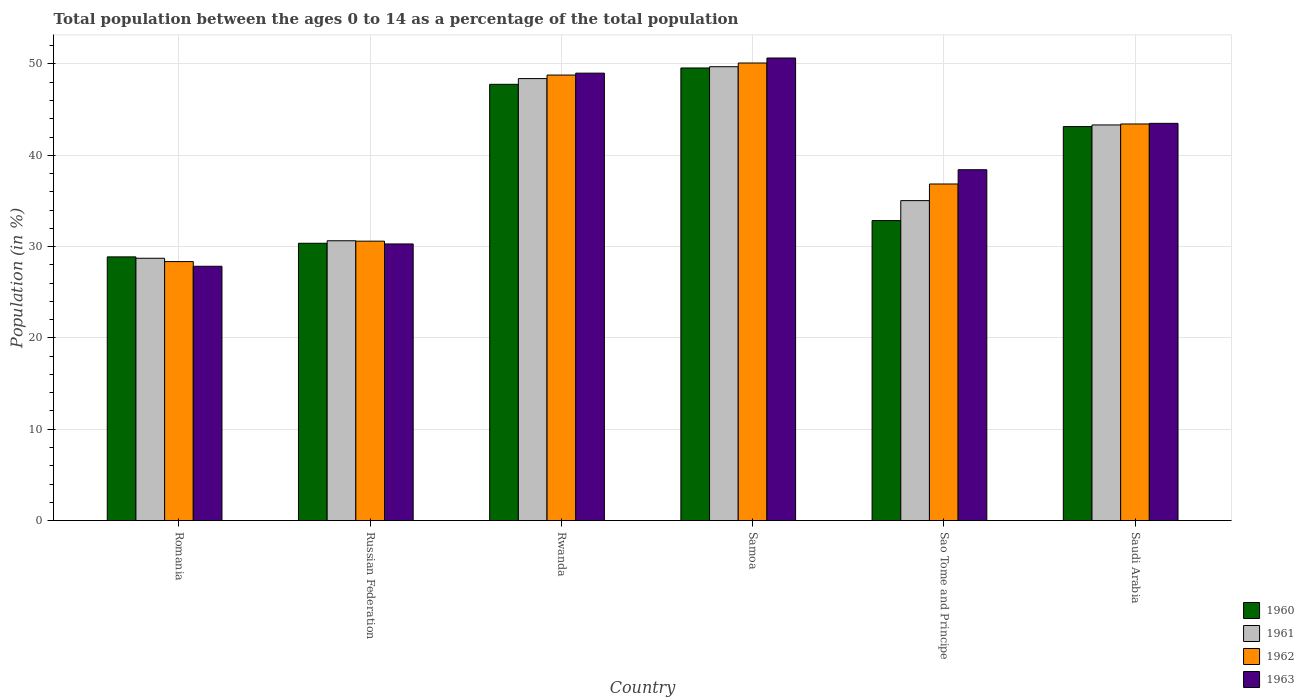How many groups of bars are there?
Give a very brief answer. 6. Are the number of bars on each tick of the X-axis equal?
Provide a succinct answer. Yes. How many bars are there on the 3rd tick from the left?
Your answer should be very brief. 4. How many bars are there on the 1st tick from the right?
Keep it short and to the point. 4. What is the label of the 3rd group of bars from the left?
Offer a terse response. Rwanda. In how many cases, is the number of bars for a given country not equal to the number of legend labels?
Provide a short and direct response. 0. What is the percentage of the population ages 0 to 14 in 1961 in Rwanda?
Your answer should be compact. 48.4. Across all countries, what is the maximum percentage of the population ages 0 to 14 in 1961?
Offer a terse response. 49.7. Across all countries, what is the minimum percentage of the population ages 0 to 14 in 1961?
Your answer should be compact. 28.73. In which country was the percentage of the population ages 0 to 14 in 1961 maximum?
Your response must be concise. Samoa. In which country was the percentage of the population ages 0 to 14 in 1962 minimum?
Give a very brief answer. Romania. What is the total percentage of the population ages 0 to 14 in 1960 in the graph?
Give a very brief answer. 232.57. What is the difference between the percentage of the population ages 0 to 14 in 1962 in Rwanda and that in Saudi Arabia?
Make the answer very short. 5.36. What is the difference between the percentage of the population ages 0 to 14 in 1961 in Romania and the percentage of the population ages 0 to 14 in 1962 in Sao Tome and Principe?
Provide a short and direct response. -8.13. What is the average percentage of the population ages 0 to 14 in 1962 per country?
Provide a succinct answer. 39.69. What is the difference between the percentage of the population ages 0 to 14 of/in 1962 and percentage of the population ages 0 to 14 of/in 1960 in Romania?
Give a very brief answer. -0.51. What is the ratio of the percentage of the population ages 0 to 14 in 1960 in Samoa to that in Sao Tome and Principe?
Keep it short and to the point. 1.51. What is the difference between the highest and the second highest percentage of the population ages 0 to 14 in 1960?
Keep it short and to the point. 6.42. What is the difference between the highest and the lowest percentage of the population ages 0 to 14 in 1963?
Give a very brief answer. 22.81. Is the sum of the percentage of the population ages 0 to 14 in 1962 in Russian Federation and Rwanda greater than the maximum percentage of the population ages 0 to 14 in 1960 across all countries?
Your answer should be compact. Yes. Is it the case that in every country, the sum of the percentage of the population ages 0 to 14 in 1961 and percentage of the population ages 0 to 14 in 1960 is greater than the sum of percentage of the population ages 0 to 14 in 1962 and percentage of the population ages 0 to 14 in 1963?
Provide a short and direct response. No. What does the 2nd bar from the right in Romania represents?
Your response must be concise. 1962. Is it the case that in every country, the sum of the percentage of the population ages 0 to 14 in 1962 and percentage of the population ages 0 to 14 in 1963 is greater than the percentage of the population ages 0 to 14 in 1961?
Keep it short and to the point. Yes. How many bars are there?
Give a very brief answer. 24. Are all the bars in the graph horizontal?
Ensure brevity in your answer.  No. How many countries are there in the graph?
Provide a succinct answer. 6. Does the graph contain any zero values?
Ensure brevity in your answer.  No. Does the graph contain grids?
Offer a terse response. Yes. What is the title of the graph?
Make the answer very short. Total population between the ages 0 to 14 as a percentage of the total population. Does "2003" appear as one of the legend labels in the graph?
Offer a very short reply. No. What is the label or title of the X-axis?
Your answer should be compact. Country. What is the Population (in %) in 1960 in Romania?
Keep it short and to the point. 28.88. What is the Population (in %) in 1961 in Romania?
Provide a succinct answer. 28.73. What is the Population (in %) in 1962 in Romania?
Your answer should be very brief. 28.36. What is the Population (in %) in 1963 in Romania?
Provide a succinct answer. 27.85. What is the Population (in %) in 1960 in Russian Federation?
Offer a very short reply. 30.37. What is the Population (in %) of 1961 in Russian Federation?
Your response must be concise. 30.64. What is the Population (in %) in 1962 in Russian Federation?
Make the answer very short. 30.6. What is the Population (in %) of 1963 in Russian Federation?
Ensure brevity in your answer.  30.29. What is the Population (in %) in 1960 in Rwanda?
Your answer should be very brief. 47.77. What is the Population (in %) of 1961 in Rwanda?
Give a very brief answer. 48.4. What is the Population (in %) of 1962 in Rwanda?
Ensure brevity in your answer.  48.79. What is the Population (in %) in 1963 in Rwanda?
Your answer should be compact. 49. What is the Population (in %) of 1960 in Samoa?
Offer a very short reply. 49.56. What is the Population (in %) in 1961 in Samoa?
Your response must be concise. 49.7. What is the Population (in %) in 1962 in Samoa?
Offer a very short reply. 50.11. What is the Population (in %) of 1963 in Samoa?
Keep it short and to the point. 50.65. What is the Population (in %) in 1960 in Sao Tome and Principe?
Your response must be concise. 32.85. What is the Population (in %) in 1961 in Sao Tome and Principe?
Your response must be concise. 35.04. What is the Population (in %) of 1962 in Sao Tome and Principe?
Offer a very short reply. 36.86. What is the Population (in %) in 1963 in Sao Tome and Principe?
Your answer should be very brief. 38.42. What is the Population (in %) of 1960 in Saudi Arabia?
Your response must be concise. 43.14. What is the Population (in %) in 1961 in Saudi Arabia?
Make the answer very short. 43.32. What is the Population (in %) of 1962 in Saudi Arabia?
Provide a short and direct response. 43.43. What is the Population (in %) in 1963 in Saudi Arabia?
Your answer should be compact. 43.5. Across all countries, what is the maximum Population (in %) of 1960?
Your answer should be compact. 49.56. Across all countries, what is the maximum Population (in %) of 1961?
Give a very brief answer. 49.7. Across all countries, what is the maximum Population (in %) of 1962?
Ensure brevity in your answer.  50.11. Across all countries, what is the maximum Population (in %) of 1963?
Ensure brevity in your answer.  50.65. Across all countries, what is the minimum Population (in %) in 1960?
Your answer should be compact. 28.88. Across all countries, what is the minimum Population (in %) of 1961?
Your answer should be very brief. 28.73. Across all countries, what is the minimum Population (in %) in 1962?
Offer a terse response. 28.36. Across all countries, what is the minimum Population (in %) in 1963?
Keep it short and to the point. 27.85. What is the total Population (in %) of 1960 in the graph?
Your answer should be compact. 232.57. What is the total Population (in %) of 1961 in the graph?
Make the answer very short. 235.83. What is the total Population (in %) of 1962 in the graph?
Your answer should be compact. 238.14. What is the total Population (in %) in 1963 in the graph?
Offer a terse response. 239.71. What is the difference between the Population (in %) in 1960 in Romania and that in Russian Federation?
Make the answer very short. -1.49. What is the difference between the Population (in %) of 1961 in Romania and that in Russian Federation?
Make the answer very short. -1.92. What is the difference between the Population (in %) of 1962 in Romania and that in Russian Federation?
Your response must be concise. -2.24. What is the difference between the Population (in %) in 1963 in Romania and that in Russian Federation?
Your answer should be compact. -2.44. What is the difference between the Population (in %) in 1960 in Romania and that in Rwanda?
Make the answer very short. -18.9. What is the difference between the Population (in %) in 1961 in Romania and that in Rwanda?
Give a very brief answer. -19.67. What is the difference between the Population (in %) in 1962 in Romania and that in Rwanda?
Offer a very short reply. -20.42. What is the difference between the Population (in %) of 1963 in Romania and that in Rwanda?
Provide a succinct answer. -21.15. What is the difference between the Population (in %) in 1960 in Romania and that in Samoa?
Make the answer very short. -20.69. What is the difference between the Population (in %) in 1961 in Romania and that in Samoa?
Your answer should be very brief. -20.97. What is the difference between the Population (in %) in 1962 in Romania and that in Samoa?
Your answer should be compact. -21.74. What is the difference between the Population (in %) of 1963 in Romania and that in Samoa?
Provide a short and direct response. -22.81. What is the difference between the Population (in %) in 1960 in Romania and that in Sao Tome and Principe?
Ensure brevity in your answer.  -3.98. What is the difference between the Population (in %) of 1961 in Romania and that in Sao Tome and Principe?
Offer a terse response. -6.31. What is the difference between the Population (in %) of 1962 in Romania and that in Sao Tome and Principe?
Provide a short and direct response. -8.5. What is the difference between the Population (in %) in 1963 in Romania and that in Sao Tome and Principe?
Your answer should be very brief. -10.57. What is the difference between the Population (in %) in 1960 in Romania and that in Saudi Arabia?
Your answer should be compact. -14.27. What is the difference between the Population (in %) of 1961 in Romania and that in Saudi Arabia?
Offer a terse response. -14.6. What is the difference between the Population (in %) of 1962 in Romania and that in Saudi Arabia?
Ensure brevity in your answer.  -15.07. What is the difference between the Population (in %) of 1963 in Romania and that in Saudi Arabia?
Your answer should be compact. -15.65. What is the difference between the Population (in %) in 1960 in Russian Federation and that in Rwanda?
Your response must be concise. -17.41. What is the difference between the Population (in %) of 1961 in Russian Federation and that in Rwanda?
Your answer should be compact. -17.76. What is the difference between the Population (in %) in 1962 in Russian Federation and that in Rwanda?
Provide a succinct answer. -18.19. What is the difference between the Population (in %) in 1963 in Russian Federation and that in Rwanda?
Offer a very short reply. -18.7. What is the difference between the Population (in %) in 1960 in Russian Federation and that in Samoa?
Make the answer very short. -19.2. What is the difference between the Population (in %) of 1961 in Russian Federation and that in Samoa?
Offer a very short reply. -19.06. What is the difference between the Population (in %) of 1962 in Russian Federation and that in Samoa?
Your answer should be compact. -19.51. What is the difference between the Population (in %) in 1963 in Russian Federation and that in Samoa?
Provide a short and direct response. -20.36. What is the difference between the Population (in %) in 1960 in Russian Federation and that in Sao Tome and Principe?
Your response must be concise. -2.48. What is the difference between the Population (in %) in 1961 in Russian Federation and that in Sao Tome and Principe?
Your answer should be compact. -4.4. What is the difference between the Population (in %) of 1962 in Russian Federation and that in Sao Tome and Principe?
Your answer should be very brief. -6.26. What is the difference between the Population (in %) of 1963 in Russian Federation and that in Sao Tome and Principe?
Provide a short and direct response. -8.13. What is the difference between the Population (in %) of 1960 in Russian Federation and that in Saudi Arabia?
Offer a very short reply. -12.78. What is the difference between the Population (in %) in 1961 in Russian Federation and that in Saudi Arabia?
Provide a short and direct response. -12.68. What is the difference between the Population (in %) of 1962 in Russian Federation and that in Saudi Arabia?
Keep it short and to the point. -12.83. What is the difference between the Population (in %) of 1963 in Russian Federation and that in Saudi Arabia?
Provide a short and direct response. -13.21. What is the difference between the Population (in %) in 1960 in Rwanda and that in Samoa?
Your answer should be very brief. -1.79. What is the difference between the Population (in %) of 1961 in Rwanda and that in Samoa?
Your answer should be compact. -1.3. What is the difference between the Population (in %) of 1962 in Rwanda and that in Samoa?
Give a very brief answer. -1.32. What is the difference between the Population (in %) of 1963 in Rwanda and that in Samoa?
Your response must be concise. -1.66. What is the difference between the Population (in %) of 1960 in Rwanda and that in Sao Tome and Principe?
Ensure brevity in your answer.  14.92. What is the difference between the Population (in %) in 1961 in Rwanda and that in Sao Tome and Principe?
Keep it short and to the point. 13.36. What is the difference between the Population (in %) of 1962 in Rwanda and that in Sao Tome and Principe?
Ensure brevity in your answer.  11.93. What is the difference between the Population (in %) of 1963 in Rwanda and that in Sao Tome and Principe?
Offer a terse response. 10.58. What is the difference between the Population (in %) in 1960 in Rwanda and that in Saudi Arabia?
Offer a terse response. 4.63. What is the difference between the Population (in %) in 1961 in Rwanda and that in Saudi Arabia?
Your response must be concise. 5.08. What is the difference between the Population (in %) in 1962 in Rwanda and that in Saudi Arabia?
Offer a terse response. 5.36. What is the difference between the Population (in %) of 1963 in Rwanda and that in Saudi Arabia?
Your answer should be compact. 5.5. What is the difference between the Population (in %) in 1960 in Samoa and that in Sao Tome and Principe?
Offer a very short reply. 16.71. What is the difference between the Population (in %) of 1961 in Samoa and that in Sao Tome and Principe?
Make the answer very short. 14.66. What is the difference between the Population (in %) in 1962 in Samoa and that in Sao Tome and Principe?
Provide a short and direct response. 13.25. What is the difference between the Population (in %) of 1963 in Samoa and that in Sao Tome and Principe?
Make the answer very short. 12.23. What is the difference between the Population (in %) of 1960 in Samoa and that in Saudi Arabia?
Provide a short and direct response. 6.42. What is the difference between the Population (in %) of 1961 in Samoa and that in Saudi Arabia?
Provide a succinct answer. 6.38. What is the difference between the Population (in %) in 1962 in Samoa and that in Saudi Arabia?
Your response must be concise. 6.68. What is the difference between the Population (in %) in 1963 in Samoa and that in Saudi Arabia?
Your answer should be very brief. 7.16. What is the difference between the Population (in %) in 1960 in Sao Tome and Principe and that in Saudi Arabia?
Give a very brief answer. -10.29. What is the difference between the Population (in %) of 1961 in Sao Tome and Principe and that in Saudi Arabia?
Provide a short and direct response. -8.29. What is the difference between the Population (in %) in 1962 in Sao Tome and Principe and that in Saudi Arabia?
Provide a succinct answer. -6.57. What is the difference between the Population (in %) in 1963 in Sao Tome and Principe and that in Saudi Arabia?
Give a very brief answer. -5.08. What is the difference between the Population (in %) in 1960 in Romania and the Population (in %) in 1961 in Russian Federation?
Provide a succinct answer. -1.77. What is the difference between the Population (in %) of 1960 in Romania and the Population (in %) of 1962 in Russian Federation?
Keep it short and to the point. -1.72. What is the difference between the Population (in %) in 1960 in Romania and the Population (in %) in 1963 in Russian Federation?
Ensure brevity in your answer.  -1.42. What is the difference between the Population (in %) of 1961 in Romania and the Population (in %) of 1962 in Russian Federation?
Your response must be concise. -1.87. What is the difference between the Population (in %) of 1961 in Romania and the Population (in %) of 1963 in Russian Federation?
Keep it short and to the point. -1.57. What is the difference between the Population (in %) of 1962 in Romania and the Population (in %) of 1963 in Russian Federation?
Your response must be concise. -1.93. What is the difference between the Population (in %) in 1960 in Romania and the Population (in %) in 1961 in Rwanda?
Ensure brevity in your answer.  -19.52. What is the difference between the Population (in %) in 1960 in Romania and the Population (in %) in 1962 in Rwanda?
Provide a short and direct response. -19.91. What is the difference between the Population (in %) of 1960 in Romania and the Population (in %) of 1963 in Rwanda?
Provide a succinct answer. -20.12. What is the difference between the Population (in %) in 1961 in Romania and the Population (in %) in 1962 in Rwanda?
Your answer should be compact. -20.06. What is the difference between the Population (in %) of 1961 in Romania and the Population (in %) of 1963 in Rwanda?
Offer a very short reply. -20.27. What is the difference between the Population (in %) of 1962 in Romania and the Population (in %) of 1963 in Rwanda?
Provide a succinct answer. -20.63. What is the difference between the Population (in %) in 1960 in Romania and the Population (in %) in 1961 in Samoa?
Your answer should be very brief. -20.82. What is the difference between the Population (in %) of 1960 in Romania and the Population (in %) of 1962 in Samoa?
Offer a terse response. -21.23. What is the difference between the Population (in %) of 1960 in Romania and the Population (in %) of 1963 in Samoa?
Your answer should be very brief. -21.78. What is the difference between the Population (in %) of 1961 in Romania and the Population (in %) of 1962 in Samoa?
Your answer should be compact. -21.38. What is the difference between the Population (in %) of 1961 in Romania and the Population (in %) of 1963 in Samoa?
Keep it short and to the point. -21.93. What is the difference between the Population (in %) of 1962 in Romania and the Population (in %) of 1963 in Samoa?
Offer a very short reply. -22.29. What is the difference between the Population (in %) of 1960 in Romania and the Population (in %) of 1961 in Sao Tome and Principe?
Give a very brief answer. -6.16. What is the difference between the Population (in %) of 1960 in Romania and the Population (in %) of 1962 in Sao Tome and Principe?
Provide a succinct answer. -7.98. What is the difference between the Population (in %) in 1960 in Romania and the Population (in %) in 1963 in Sao Tome and Principe?
Your answer should be very brief. -9.54. What is the difference between the Population (in %) of 1961 in Romania and the Population (in %) of 1962 in Sao Tome and Principe?
Your response must be concise. -8.13. What is the difference between the Population (in %) in 1961 in Romania and the Population (in %) in 1963 in Sao Tome and Principe?
Make the answer very short. -9.69. What is the difference between the Population (in %) of 1962 in Romania and the Population (in %) of 1963 in Sao Tome and Principe?
Offer a terse response. -10.06. What is the difference between the Population (in %) of 1960 in Romania and the Population (in %) of 1961 in Saudi Arabia?
Ensure brevity in your answer.  -14.45. What is the difference between the Population (in %) of 1960 in Romania and the Population (in %) of 1962 in Saudi Arabia?
Keep it short and to the point. -14.55. What is the difference between the Population (in %) in 1960 in Romania and the Population (in %) in 1963 in Saudi Arabia?
Your answer should be very brief. -14.62. What is the difference between the Population (in %) of 1961 in Romania and the Population (in %) of 1962 in Saudi Arabia?
Keep it short and to the point. -14.7. What is the difference between the Population (in %) in 1961 in Romania and the Population (in %) in 1963 in Saudi Arabia?
Offer a very short reply. -14.77. What is the difference between the Population (in %) in 1962 in Romania and the Population (in %) in 1963 in Saudi Arabia?
Provide a short and direct response. -15.14. What is the difference between the Population (in %) of 1960 in Russian Federation and the Population (in %) of 1961 in Rwanda?
Ensure brevity in your answer.  -18.03. What is the difference between the Population (in %) of 1960 in Russian Federation and the Population (in %) of 1962 in Rwanda?
Provide a short and direct response. -18.42. What is the difference between the Population (in %) of 1960 in Russian Federation and the Population (in %) of 1963 in Rwanda?
Your answer should be compact. -18.63. What is the difference between the Population (in %) in 1961 in Russian Federation and the Population (in %) in 1962 in Rwanda?
Offer a terse response. -18.14. What is the difference between the Population (in %) of 1961 in Russian Federation and the Population (in %) of 1963 in Rwanda?
Give a very brief answer. -18.35. What is the difference between the Population (in %) of 1962 in Russian Federation and the Population (in %) of 1963 in Rwanda?
Keep it short and to the point. -18.4. What is the difference between the Population (in %) in 1960 in Russian Federation and the Population (in %) in 1961 in Samoa?
Ensure brevity in your answer.  -19.33. What is the difference between the Population (in %) of 1960 in Russian Federation and the Population (in %) of 1962 in Samoa?
Offer a very short reply. -19.74. What is the difference between the Population (in %) in 1960 in Russian Federation and the Population (in %) in 1963 in Samoa?
Offer a very short reply. -20.29. What is the difference between the Population (in %) in 1961 in Russian Federation and the Population (in %) in 1962 in Samoa?
Provide a succinct answer. -19.46. What is the difference between the Population (in %) of 1961 in Russian Federation and the Population (in %) of 1963 in Samoa?
Make the answer very short. -20.01. What is the difference between the Population (in %) in 1962 in Russian Federation and the Population (in %) in 1963 in Samoa?
Provide a short and direct response. -20.06. What is the difference between the Population (in %) in 1960 in Russian Federation and the Population (in %) in 1961 in Sao Tome and Principe?
Make the answer very short. -4.67. What is the difference between the Population (in %) in 1960 in Russian Federation and the Population (in %) in 1962 in Sao Tome and Principe?
Offer a terse response. -6.49. What is the difference between the Population (in %) in 1960 in Russian Federation and the Population (in %) in 1963 in Sao Tome and Principe?
Provide a succinct answer. -8.05. What is the difference between the Population (in %) in 1961 in Russian Federation and the Population (in %) in 1962 in Sao Tome and Principe?
Give a very brief answer. -6.22. What is the difference between the Population (in %) in 1961 in Russian Federation and the Population (in %) in 1963 in Sao Tome and Principe?
Your answer should be very brief. -7.78. What is the difference between the Population (in %) in 1962 in Russian Federation and the Population (in %) in 1963 in Sao Tome and Principe?
Your answer should be compact. -7.82. What is the difference between the Population (in %) in 1960 in Russian Federation and the Population (in %) in 1961 in Saudi Arabia?
Provide a short and direct response. -12.96. What is the difference between the Population (in %) of 1960 in Russian Federation and the Population (in %) of 1962 in Saudi Arabia?
Offer a terse response. -13.06. What is the difference between the Population (in %) in 1960 in Russian Federation and the Population (in %) in 1963 in Saudi Arabia?
Provide a succinct answer. -13.13. What is the difference between the Population (in %) of 1961 in Russian Federation and the Population (in %) of 1962 in Saudi Arabia?
Offer a very short reply. -12.79. What is the difference between the Population (in %) of 1961 in Russian Federation and the Population (in %) of 1963 in Saudi Arabia?
Your response must be concise. -12.86. What is the difference between the Population (in %) in 1962 in Russian Federation and the Population (in %) in 1963 in Saudi Arabia?
Make the answer very short. -12.9. What is the difference between the Population (in %) in 1960 in Rwanda and the Population (in %) in 1961 in Samoa?
Keep it short and to the point. -1.93. What is the difference between the Population (in %) of 1960 in Rwanda and the Population (in %) of 1962 in Samoa?
Make the answer very short. -2.33. What is the difference between the Population (in %) of 1960 in Rwanda and the Population (in %) of 1963 in Samoa?
Offer a terse response. -2.88. What is the difference between the Population (in %) of 1961 in Rwanda and the Population (in %) of 1962 in Samoa?
Provide a succinct answer. -1.71. What is the difference between the Population (in %) in 1961 in Rwanda and the Population (in %) in 1963 in Samoa?
Your answer should be very brief. -2.25. What is the difference between the Population (in %) in 1962 in Rwanda and the Population (in %) in 1963 in Samoa?
Your answer should be compact. -1.87. What is the difference between the Population (in %) in 1960 in Rwanda and the Population (in %) in 1961 in Sao Tome and Principe?
Offer a very short reply. 12.74. What is the difference between the Population (in %) of 1960 in Rwanda and the Population (in %) of 1962 in Sao Tome and Principe?
Your answer should be very brief. 10.91. What is the difference between the Population (in %) in 1960 in Rwanda and the Population (in %) in 1963 in Sao Tome and Principe?
Your answer should be very brief. 9.35. What is the difference between the Population (in %) of 1961 in Rwanda and the Population (in %) of 1962 in Sao Tome and Principe?
Provide a short and direct response. 11.54. What is the difference between the Population (in %) of 1961 in Rwanda and the Population (in %) of 1963 in Sao Tome and Principe?
Provide a short and direct response. 9.98. What is the difference between the Population (in %) of 1962 in Rwanda and the Population (in %) of 1963 in Sao Tome and Principe?
Keep it short and to the point. 10.37. What is the difference between the Population (in %) of 1960 in Rwanda and the Population (in %) of 1961 in Saudi Arabia?
Your answer should be very brief. 4.45. What is the difference between the Population (in %) of 1960 in Rwanda and the Population (in %) of 1962 in Saudi Arabia?
Provide a short and direct response. 4.34. What is the difference between the Population (in %) in 1960 in Rwanda and the Population (in %) in 1963 in Saudi Arabia?
Give a very brief answer. 4.28. What is the difference between the Population (in %) of 1961 in Rwanda and the Population (in %) of 1962 in Saudi Arabia?
Your answer should be very brief. 4.97. What is the difference between the Population (in %) in 1961 in Rwanda and the Population (in %) in 1963 in Saudi Arabia?
Your answer should be compact. 4.9. What is the difference between the Population (in %) of 1962 in Rwanda and the Population (in %) of 1963 in Saudi Arabia?
Make the answer very short. 5.29. What is the difference between the Population (in %) in 1960 in Samoa and the Population (in %) in 1961 in Sao Tome and Principe?
Ensure brevity in your answer.  14.52. What is the difference between the Population (in %) of 1960 in Samoa and the Population (in %) of 1962 in Sao Tome and Principe?
Provide a short and direct response. 12.7. What is the difference between the Population (in %) of 1960 in Samoa and the Population (in %) of 1963 in Sao Tome and Principe?
Keep it short and to the point. 11.14. What is the difference between the Population (in %) of 1961 in Samoa and the Population (in %) of 1962 in Sao Tome and Principe?
Provide a succinct answer. 12.84. What is the difference between the Population (in %) of 1961 in Samoa and the Population (in %) of 1963 in Sao Tome and Principe?
Give a very brief answer. 11.28. What is the difference between the Population (in %) of 1962 in Samoa and the Population (in %) of 1963 in Sao Tome and Principe?
Your answer should be very brief. 11.69. What is the difference between the Population (in %) in 1960 in Samoa and the Population (in %) in 1961 in Saudi Arabia?
Ensure brevity in your answer.  6.24. What is the difference between the Population (in %) in 1960 in Samoa and the Population (in %) in 1962 in Saudi Arabia?
Ensure brevity in your answer.  6.13. What is the difference between the Population (in %) in 1960 in Samoa and the Population (in %) in 1963 in Saudi Arabia?
Your answer should be compact. 6.06. What is the difference between the Population (in %) of 1961 in Samoa and the Population (in %) of 1962 in Saudi Arabia?
Keep it short and to the point. 6.27. What is the difference between the Population (in %) in 1961 in Samoa and the Population (in %) in 1963 in Saudi Arabia?
Your response must be concise. 6.2. What is the difference between the Population (in %) of 1962 in Samoa and the Population (in %) of 1963 in Saudi Arabia?
Provide a short and direct response. 6.61. What is the difference between the Population (in %) of 1960 in Sao Tome and Principe and the Population (in %) of 1961 in Saudi Arabia?
Offer a terse response. -10.47. What is the difference between the Population (in %) of 1960 in Sao Tome and Principe and the Population (in %) of 1962 in Saudi Arabia?
Your answer should be very brief. -10.58. What is the difference between the Population (in %) in 1960 in Sao Tome and Principe and the Population (in %) in 1963 in Saudi Arabia?
Offer a very short reply. -10.65. What is the difference between the Population (in %) of 1961 in Sao Tome and Principe and the Population (in %) of 1962 in Saudi Arabia?
Provide a succinct answer. -8.39. What is the difference between the Population (in %) of 1961 in Sao Tome and Principe and the Population (in %) of 1963 in Saudi Arabia?
Give a very brief answer. -8.46. What is the difference between the Population (in %) in 1962 in Sao Tome and Principe and the Population (in %) in 1963 in Saudi Arabia?
Your response must be concise. -6.64. What is the average Population (in %) in 1960 per country?
Make the answer very short. 38.76. What is the average Population (in %) in 1961 per country?
Offer a terse response. 39.3. What is the average Population (in %) in 1962 per country?
Keep it short and to the point. 39.69. What is the average Population (in %) in 1963 per country?
Make the answer very short. 39.95. What is the difference between the Population (in %) of 1960 and Population (in %) of 1961 in Romania?
Make the answer very short. 0.15. What is the difference between the Population (in %) of 1960 and Population (in %) of 1962 in Romania?
Give a very brief answer. 0.51. What is the difference between the Population (in %) of 1960 and Population (in %) of 1963 in Romania?
Keep it short and to the point. 1.03. What is the difference between the Population (in %) of 1961 and Population (in %) of 1962 in Romania?
Make the answer very short. 0.36. What is the difference between the Population (in %) of 1961 and Population (in %) of 1963 in Romania?
Ensure brevity in your answer.  0.88. What is the difference between the Population (in %) of 1962 and Population (in %) of 1963 in Romania?
Ensure brevity in your answer.  0.51. What is the difference between the Population (in %) in 1960 and Population (in %) in 1961 in Russian Federation?
Your answer should be very brief. -0.28. What is the difference between the Population (in %) of 1960 and Population (in %) of 1962 in Russian Federation?
Offer a very short reply. -0.23. What is the difference between the Population (in %) in 1960 and Population (in %) in 1963 in Russian Federation?
Give a very brief answer. 0.07. What is the difference between the Population (in %) in 1961 and Population (in %) in 1962 in Russian Federation?
Give a very brief answer. 0.04. What is the difference between the Population (in %) of 1961 and Population (in %) of 1963 in Russian Federation?
Make the answer very short. 0.35. What is the difference between the Population (in %) of 1962 and Population (in %) of 1963 in Russian Federation?
Offer a terse response. 0.3. What is the difference between the Population (in %) of 1960 and Population (in %) of 1961 in Rwanda?
Make the answer very short. -0.63. What is the difference between the Population (in %) in 1960 and Population (in %) in 1962 in Rwanda?
Make the answer very short. -1.01. What is the difference between the Population (in %) of 1960 and Population (in %) of 1963 in Rwanda?
Your response must be concise. -1.22. What is the difference between the Population (in %) of 1961 and Population (in %) of 1962 in Rwanda?
Make the answer very short. -0.39. What is the difference between the Population (in %) in 1961 and Population (in %) in 1963 in Rwanda?
Provide a succinct answer. -0.6. What is the difference between the Population (in %) in 1962 and Population (in %) in 1963 in Rwanda?
Keep it short and to the point. -0.21. What is the difference between the Population (in %) of 1960 and Population (in %) of 1961 in Samoa?
Give a very brief answer. -0.14. What is the difference between the Population (in %) of 1960 and Population (in %) of 1962 in Samoa?
Make the answer very short. -0.54. What is the difference between the Population (in %) of 1960 and Population (in %) of 1963 in Samoa?
Your answer should be compact. -1.09. What is the difference between the Population (in %) of 1961 and Population (in %) of 1962 in Samoa?
Your answer should be very brief. -0.41. What is the difference between the Population (in %) in 1961 and Population (in %) in 1963 in Samoa?
Offer a terse response. -0.95. What is the difference between the Population (in %) in 1962 and Population (in %) in 1963 in Samoa?
Provide a succinct answer. -0.55. What is the difference between the Population (in %) in 1960 and Population (in %) in 1961 in Sao Tome and Principe?
Your answer should be very brief. -2.19. What is the difference between the Population (in %) of 1960 and Population (in %) of 1962 in Sao Tome and Principe?
Your answer should be compact. -4.01. What is the difference between the Population (in %) in 1960 and Population (in %) in 1963 in Sao Tome and Principe?
Your answer should be compact. -5.57. What is the difference between the Population (in %) in 1961 and Population (in %) in 1962 in Sao Tome and Principe?
Your answer should be compact. -1.82. What is the difference between the Population (in %) in 1961 and Population (in %) in 1963 in Sao Tome and Principe?
Offer a terse response. -3.38. What is the difference between the Population (in %) of 1962 and Population (in %) of 1963 in Sao Tome and Principe?
Provide a succinct answer. -1.56. What is the difference between the Population (in %) of 1960 and Population (in %) of 1961 in Saudi Arabia?
Provide a succinct answer. -0.18. What is the difference between the Population (in %) of 1960 and Population (in %) of 1962 in Saudi Arabia?
Provide a succinct answer. -0.28. What is the difference between the Population (in %) of 1960 and Population (in %) of 1963 in Saudi Arabia?
Give a very brief answer. -0.35. What is the difference between the Population (in %) of 1961 and Population (in %) of 1962 in Saudi Arabia?
Make the answer very short. -0.11. What is the difference between the Population (in %) in 1961 and Population (in %) in 1963 in Saudi Arabia?
Your answer should be compact. -0.17. What is the difference between the Population (in %) in 1962 and Population (in %) in 1963 in Saudi Arabia?
Your answer should be very brief. -0.07. What is the ratio of the Population (in %) in 1960 in Romania to that in Russian Federation?
Offer a very short reply. 0.95. What is the ratio of the Population (in %) of 1961 in Romania to that in Russian Federation?
Make the answer very short. 0.94. What is the ratio of the Population (in %) of 1962 in Romania to that in Russian Federation?
Provide a succinct answer. 0.93. What is the ratio of the Population (in %) of 1963 in Romania to that in Russian Federation?
Your answer should be very brief. 0.92. What is the ratio of the Population (in %) in 1960 in Romania to that in Rwanda?
Your answer should be very brief. 0.6. What is the ratio of the Population (in %) of 1961 in Romania to that in Rwanda?
Offer a very short reply. 0.59. What is the ratio of the Population (in %) in 1962 in Romania to that in Rwanda?
Provide a succinct answer. 0.58. What is the ratio of the Population (in %) in 1963 in Romania to that in Rwanda?
Provide a succinct answer. 0.57. What is the ratio of the Population (in %) in 1960 in Romania to that in Samoa?
Provide a succinct answer. 0.58. What is the ratio of the Population (in %) of 1961 in Romania to that in Samoa?
Provide a short and direct response. 0.58. What is the ratio of the Population (in %) of 1962 in Romania to that in Samoa?
Provide a short and direct response. 0.57. What is the ratio of the Population (in %) of 1963 in Romania to that in Samoa?
Your answer should be very brief. 0.55. What is the ratio of the Population (in %) in 1960 in Romania to that in Sao Tome and Principe?
Your answer should be compact. 0.88. What is the ratio of the Population (in %) in 1961 in Romania to that in Sao Tome and Principe?
Ensure brevity in your answer.  0.82. What is the ratio of the Population (in %) of 1962 in Romania to that in Sao Tome and Principe?
Offer a very short reply. 0.77. What is the ratio of the Population (in %) in 1963 in Romania to that in Sao Tome and Principe?
Provide a short and direct response. 0.72. What is the ratio of the Population (in %) of 1960 in Romania to that in Saudi Arabia?
Give a very brief answer. 0.67. What is the ratio of the Population (in %) of 1961 in Romania to that in Saudi Arabia?
Ensure brevity in your answer.  0.66. What is the ratio of the Population (in %) of 1962 in Romania to that in Saudi Arabia?
Make the answer very short. 0.65. What is the ratio of the Population (in %) of 1963 in Romania to that in Saudi Arabia?
Offer a very short reply. 0.64. What is the ratio of the Population (in %) of 1960 in Russian Federation to that in Rwanda?
Your response must be concise. 0.64. What is the ratio of the Population (in %) of 1961 in Russian Federation to that in Rwanda?
Offer a very short reply. 0.63. What is the ratio of the Population (in %) of 1962 in Russian Federation to that in Rwanda?
Provide a succinct answer. 0.63. What is the ratio of the Population (in %) of 1963 in Russian Federation to that in Rwanda?
Your answer should be very brief. 0.62. What is the ratio of the Population (in %) of 1960 in Russian Federation to that in Samoa?
Your answer should be compact. 0.61. What is the ratio of the Population (in %) of 1961 in Russian Federation to that in Samoa?
Provide a short and direct response. 0.62. What is the ratio of the Population (in %) in 1962 in Russian Federation to that in Samoa?
Offer a terse response. 0.61. What is the ratio of the Population (in %) in 1963 in Russian Federation to that in Samoa?
Give a very brief answer. 0.6. What is the ratio of the Population (in %) of 1960 in Russian Federation to that in Sao Tome and Principe?
Provide a short and direct response. 0.92. What is the ratio of the Population (in %) of 1961 in Russian Federation to that in Sao Tome and Principe?
Offer a very short reply. 0.87. What is the ratio of the Population (in %) in 1962 in Russian Federation to that in Sao Tome and Principe?
Make the answer very short. 0.83. What is the ratio of the Population (in %) of 1963 in Russian Federation to that in Sao Tome and Principe?
Offer a terse response. 0.79. What is the ratio of the Population (in %) in 1960 in Russian Federation to that in Saudi Arabia?
Provide a succinct answer. 0.7. What is the ratio of the Population (in %) in 1961 in Russian Federation to that in Saudi Arabia?
Ensure brevity in your answer.  0.71. What is the ratio of the Population (in %) in 1962 in Russian Federation to that in Saudi Arabia?
Your response must be concise. 0.7. What is the ratio of the Population (in %) in 1963 in Russian Federation to that in Saudi Arabia?
Ensure brevity in your answer.  0.7. What is the ratio of the Population (in %) of 1960 in Rwanda to that in Samoa?
Give a very brief answer. 0.96. What is the ratio of the Population (in %) of 1961 in Rwanda to that in Samoa?
Give a very brief answer. 0.97. What is the ratio of the Population (in %) of 1962 in Rwanda to that in Samoa?
Give a very brief answer. 0.97. What is the ratio of the Population (in %) of 1963 in Rwanda to that in Samoa?
Provide a succinct answer. 0.97. What is the ratio of the Population (in %) of 1960 in Rwanda to that in Sao Tome and Principe?
Your answer should be compact. 1.45. What is the ratio of the Population (in %) in 1961 in Rwanda to that in Sao Tome and Principe?
Provide a succinct answer. 1.38. What is the ratio of the Population (in %) in 1962 in Rwanda to that in Sao Tome and Principe?
Offer a very short reply. 1.32. What is the ratio of the Population (in %) in 1963 in Rwanda to that in Sao Tome and Principe?
Your answer should be compact. 1.28. What is the ratio of the Population (in %) of 1960 in Rwanda to that in Saudi Arabia?
Your answer should be compact. 1.11. What is the ratio of the Population (in %) in 1961 in Rwanda to that in Saudi Arabia?
Offer a terse response. 1.12. What is the ratio of the Population (in %) of 1962 in Rwanda to that in Saudi Arabia?
Make the answer very short. 1.12. What is the ratio of the Population (in %) in 1963 in Rwanda to that in Saudi Arabia?
Keep it short and to the point. 1.13. What is the ratio of the Population (in %) of 1960 in Samoa to that in Sao Tome and Principe?
Keep it short and to the point. 1.51. What is the ratio of the Population (in %) in 1961 in Samoa to that in Sao Tome and Principe?
Your response must be concise. 1.42. What is the ratio of the Population (in %) of 1962 in Samoa to that in Sao Tome and Principe?
Give a very brief answer. 1.36. What is the ratio of the Population (in %) of 1963 in Samoa to that in Sao Tome and Principe?
Your answer should be very brief. 1.32. What is the ratio of the Population (in %) of 1960 in Samoa to that in Saudi Arabia?
Keep it short and to the point. 1.15. What is the ratio of the Population (in %) in 1961 in Samoa to that in Saudi Arabia?
Your answer should be very brief. 1.15. What is the ratio of the Population (in %) in 1962 in Samoa to that in Saudi Arabia?
Provide a short and direct response. 1.15. What is the ratio of the Population (in %) of 1963 in Samoa to that in Saudi Arabia?
Your answer should be compact. 1.16. What is the ratio of the Population (in %) in 1960 in Sao Tome and Principe to that in Saudi Arabia?
Your response must be concise. 0.76. What is the ratio of the Population (in %) of 1961 in Sao Tome and Principe to that in Saudi Arabia?
Provide a succinct answer. 0.81. What is the ratio of the Population (in %) in 1962 in Sao Tome and Principe to that in Saudi Arabia?
Offer a terse response. 0.85. What is the ratio of the Population (in %) of 1963 in Sao Tome and Principe to that in Saudi Arabia?
Your answer should be compact. 0.88. What is the difference between the highest and the second highest Population (in %) in 1960?
Ensure brevity in your answer.  1.79. What is the difference between the highest and the second highest Population (in %) of 1961?
Make the answer very short. 1.3. What is the difference between the highest and the second highest Population (in %) of 1962?
Offer a terse response. 1.32. What is the difference between the highest and the second highest Population (in %) of 1963?
Your response must be concise. 1.66. What is the difference between the highest and the lowest Population (in %) of 1960?
Keep it short and to the point. 20.69. What is the difference between the highest and the lowest Population (in %) in 1961?
Give a very brief answer. 20.97. What is the difference between the highest and the lowest Population (in %) of 1962?
Make the answer very short. 21.74. What is the difference between the highest and the lowest Population (in %) of 1963?
Ensure brevity in your answer.  22.81. 